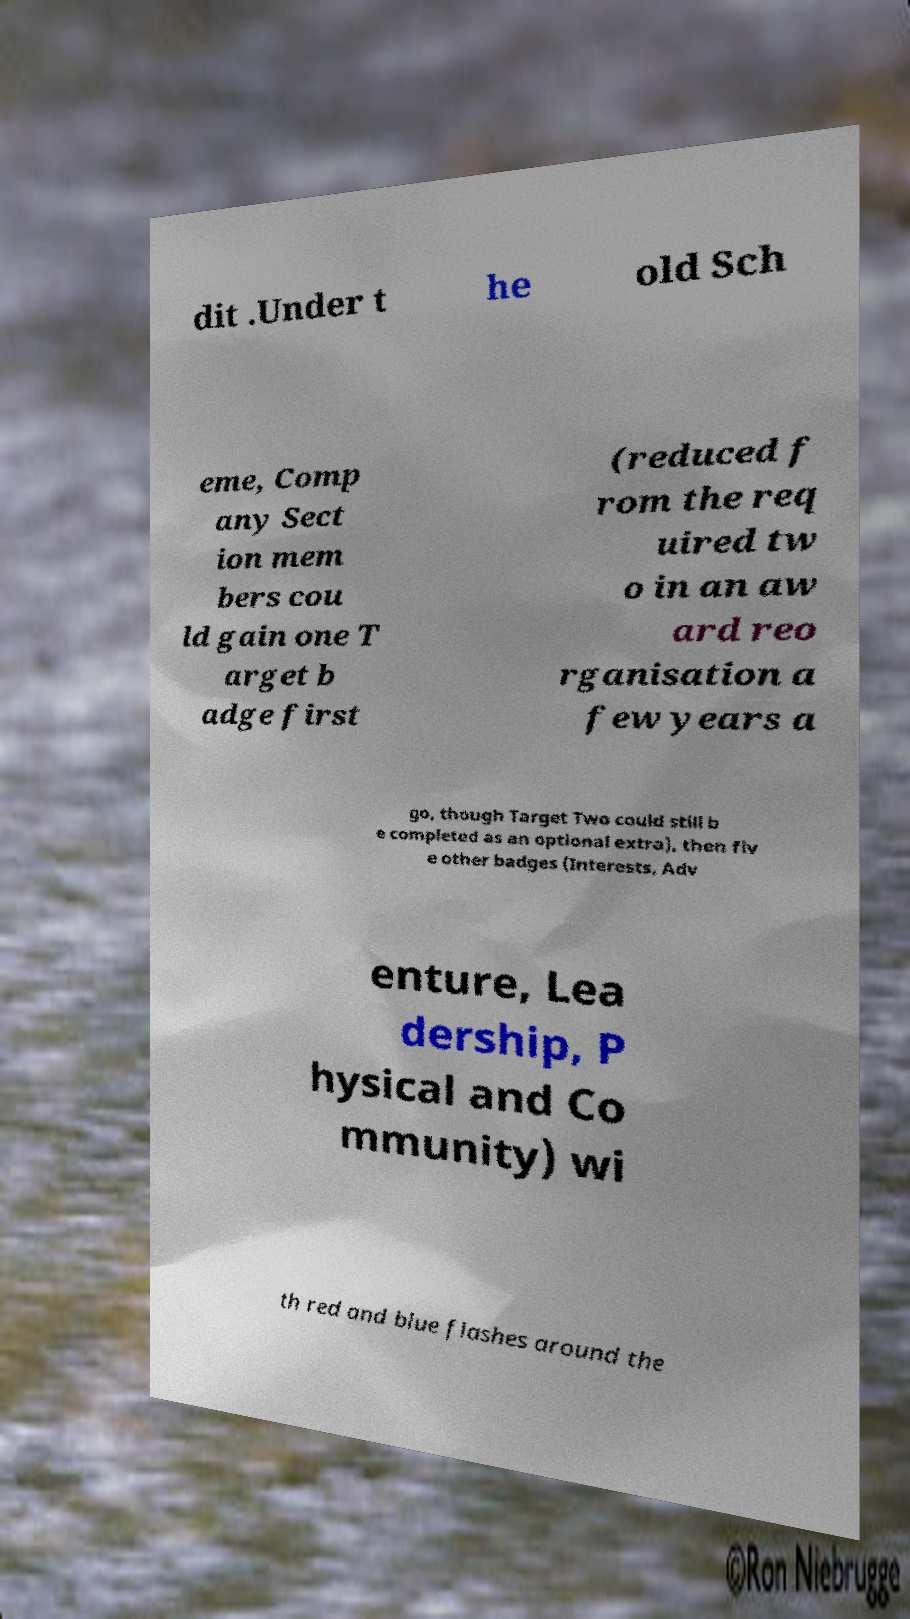I need the written content from this picture converted into text. Can you do that? dit .Under t he old Sch eme, Comp any Sect ion mem bers cou ld gain one T arget b adge first (reduced f rom the req uired tw o in an aw ard reo rganisation a few years a go, though Target Two could still b e completed as an optional extra), then fiv e other badges (Interests, Adv enture, Lea dership, P hysical and Co mmunity) wi th red and blue flashes around the 